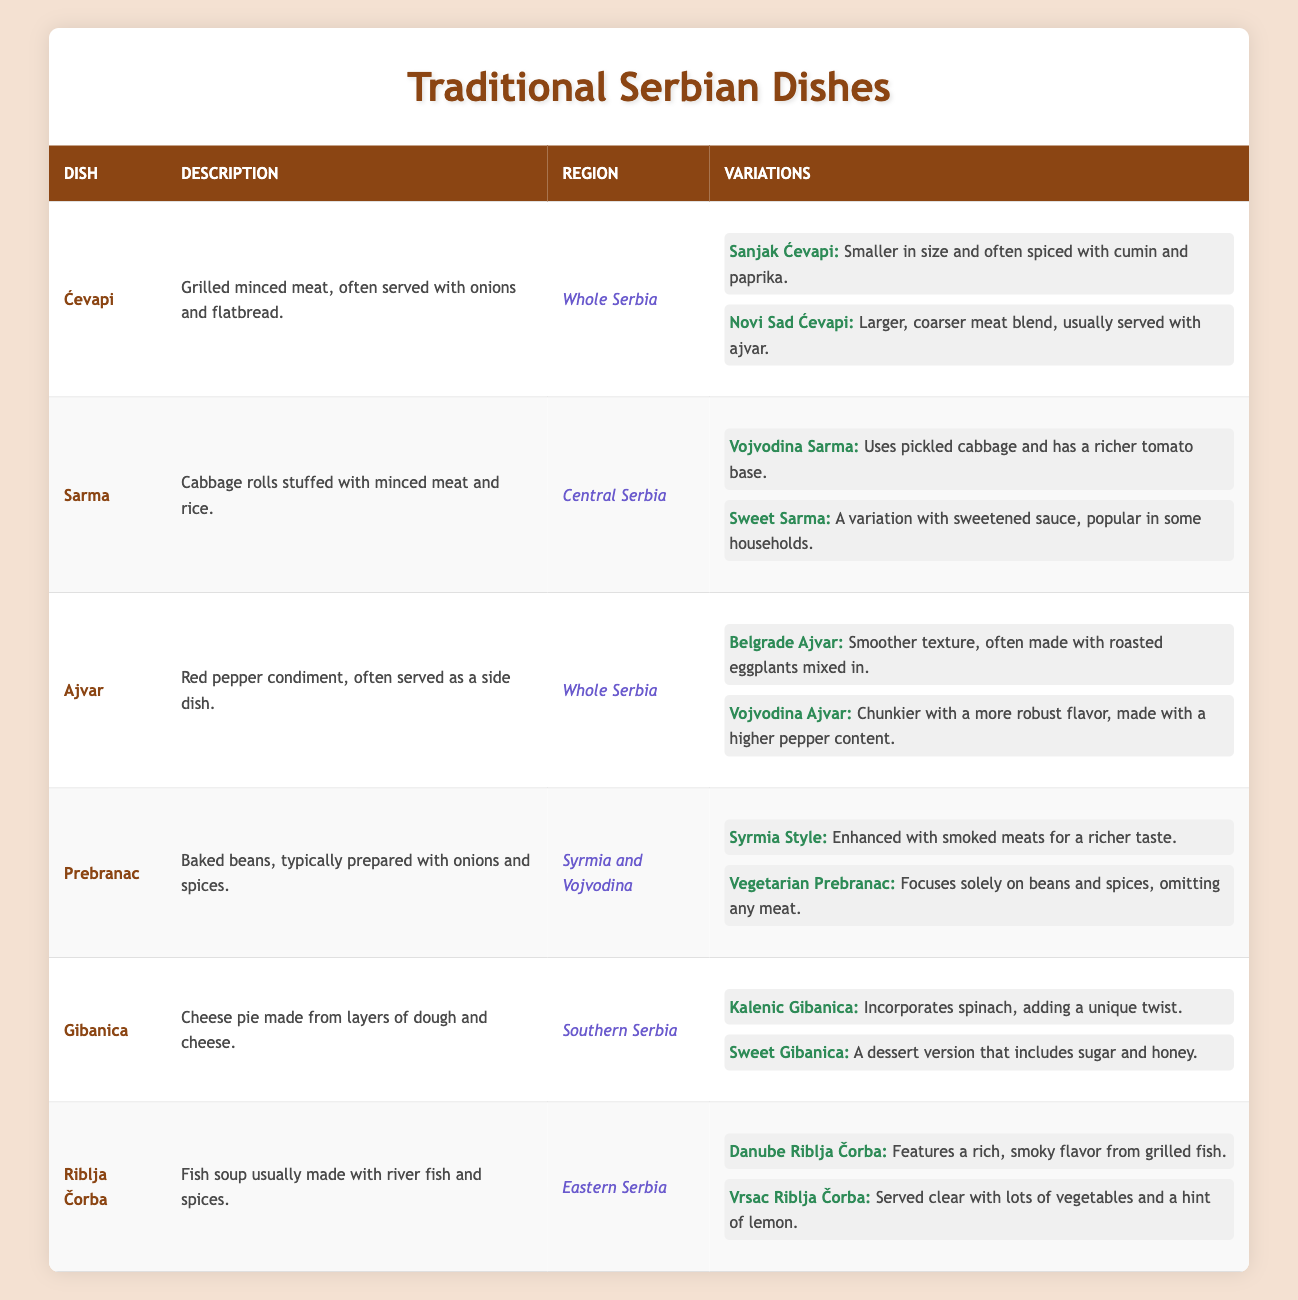What is the description of Ćevapi? The table shows that Ćevapi is described as grilled minced meat, often served with onions and flatbread.
Answer: Grilled minced meat, often served with onions and flatbread Which dish includes pickled cabbage in its Vojvodina variation? According to the table, the Vojvodina Sarma variation of Sarma uses pickled cabbage, making it rich with a tomato base.
Answer: Sarma How many variations does Ajvar have listed in the table? The table lists two variations of Ajvar: Belgrade Ajvar and Vojvodina Ajvar, which means the count is 2.
Answer: 2 Is Gibanica served in Southern Serbia? Yes, the table states that Gibanica is a dish from Southern Serbia.
Answer: Yes What is the main ingredient of Sarma? The main ingredient of Sarma, according to the table, is cabbage rolls stuffed with minced meat and rice.
Answer: Cabbage rolls stuffed with minced meat and rice Which dish variations use eggplants in Ajvar? The table mentions Belgrade Ajvar as a variation that often includes roasted eggplants mixed in, along with the red pepper base.
Answer: Belgrade Ajvar Considering the regions listed, which dish can be found throughout the whole of Serbia? Both Ćevapi and Ajvar are noted in the table to be available throughout the entire country.
Answer: Ćevapi and Ajvar What is the difference between Sanjak Ćevapi and Novi Sad Ćevapi? Sanjak Ćevapi are smaller and spiced with cumin and paprika, while Novi Sad Ćevapi are larger, with a coarser meat blend usually served with ajvar.
Answer: Size and seasoning differences If you want a vegetarian version, which dish would you choose? The table describes a vegetarian option for Prebranac, which focuses solely on beans and spices.
Answer: Prebranac Which fish soup variation features a rich, smoky flavor? The Danube Riblja Čorba variation is highlighted in the table as having a rich, smoky flavor from grilled fish.
Answer: Danube Riblja Čorba How many dishes are listed from Eastern Serbia? The table indicates that there is one dish from Eastern Serbia: Riblja Čorba.
Answer: 1 Name a variation of Gibanica that incorporates spinach. The table lists Kalenic Gibanica as a variation that incorporates spinach into the cheese pie.
Answer: Kalenic Gibanica Which dishes have variations that involve different styles of preparation? The table shows multiple dishes with variations: Ćevapi, Sarma, Ajvar, Prebranac, Gibanica, and Riblja Čorba, highlighting their diverse regional preparations.
Answer: Ćevapi, Sarma, Ajvar, Prebranac, Gibanica, Riblja Čorba 